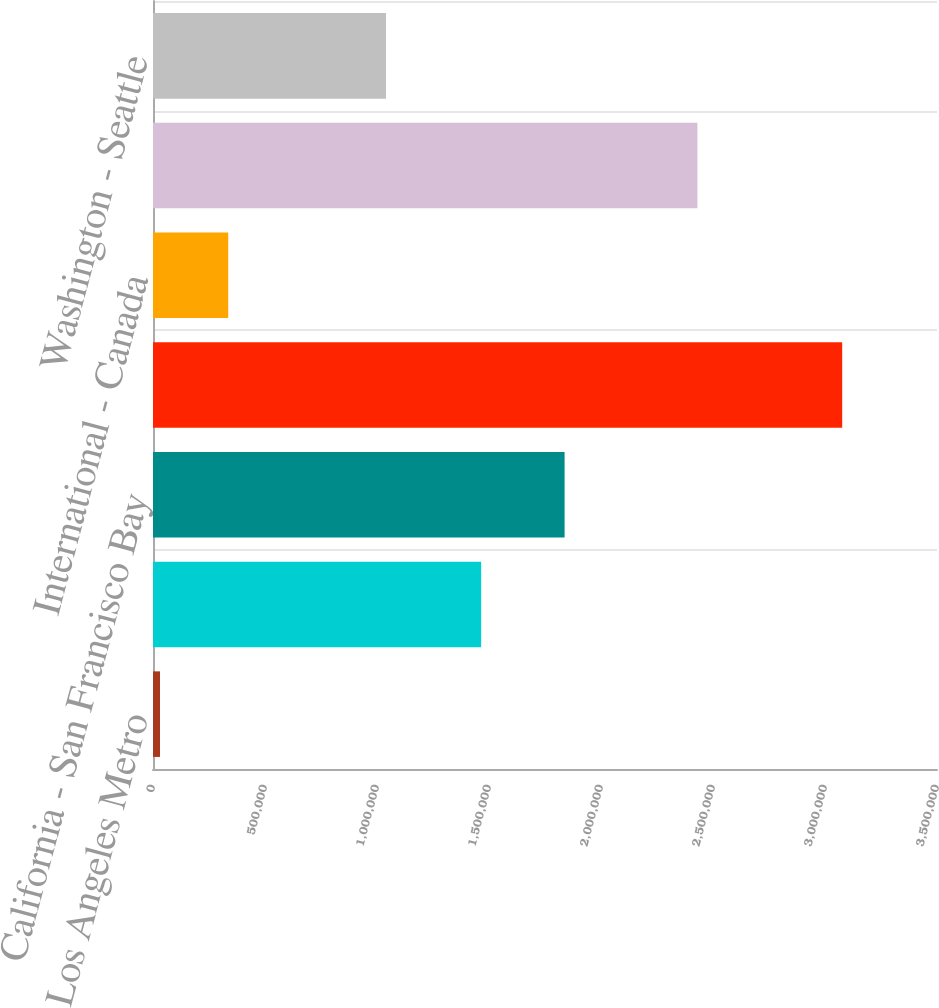Convert chart to OTSL. <chart><loc_0><loc_0><loc_500><loc_500><bar_chart><fcel>California - Los Angeles Metro<fcel>California - San Diego<fcel>California - San Francisco Bay<fcel>Eastern Massachusetts<fcel>International - Canada<fcel>Suburban Washington DC<fcel>Washington - Seattle<nl><fcel>31343<fcel>1.46503e+06<fcel>1.83746e+06<fcel>3.07669e+06<fcel>335878<fcel>2.4304e+06<fcel>1.04011e+06<nl></chart> 